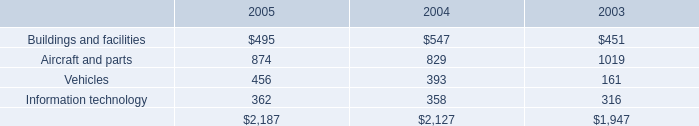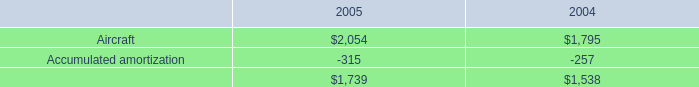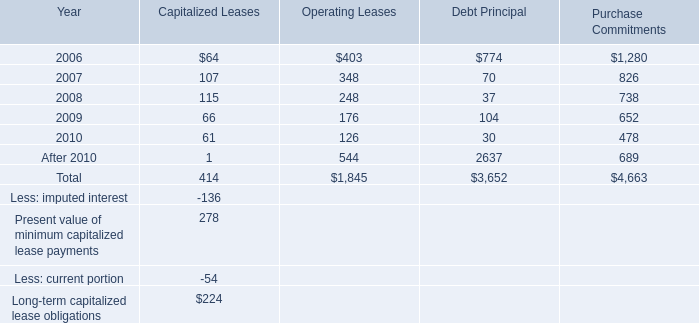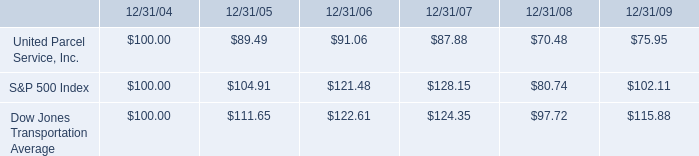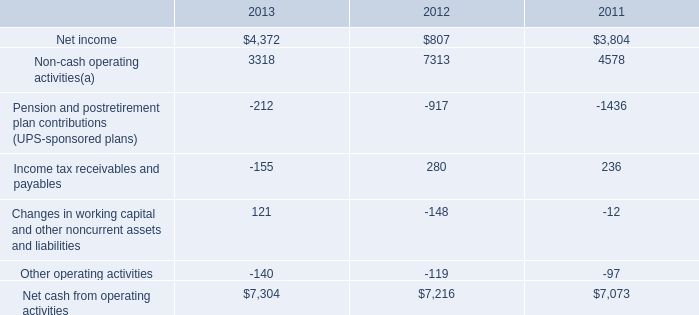what was the percentage cumulative return on investment for united parcel service inc . for the five year period ended 12/31/09? 
Computations: ((75.95 - 100) / 100)
Answer: -0.2405. 